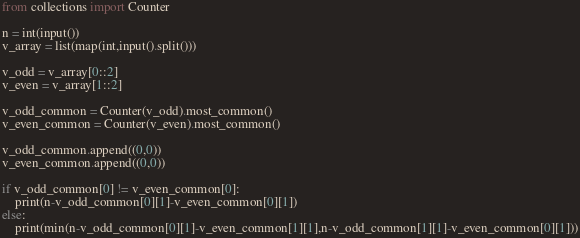<code> <loc_0><loc_0><loc_500><loc_500><_Python_>from collections import Counter
 
n = int(input())
v_array = list(map(int,input().split()))
 
v_odd = v_array[0::2]
v_even = v_array[1::2]
 
v_odd_common = Counter(v_odd).most_common()
v_even_common = Counter(v_even).most_common()

v_odd_common.append((0,0))
v_even_common.append((0,0))

if v_odd_common[0] != v_even_common[0]:
    print(n-v_odd_common[0][1]-v_even_common[0][1])
else:
    print(min(n-v_odd_common[0][1]-v_even_common[1][1],n-v_odd_common[1][1]-v_even_common[0][1]))</code> 